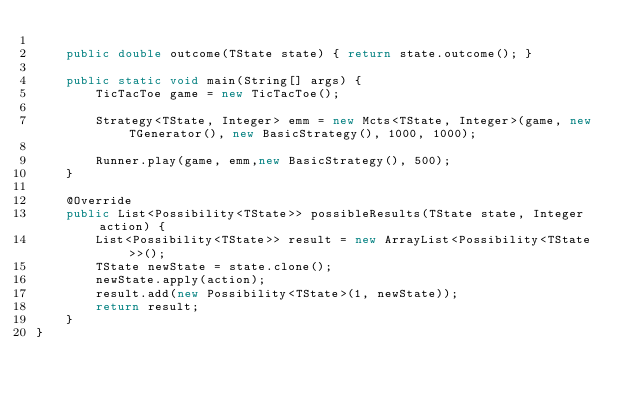<code> <loc_0><loc_0><loc_500><loc_500><_Java_>	
	public double outcome(TState state) { return state.outcome(); }
	
    public static void main(String[] args) {
		TicTacToe game = new TicTacToe();
				
		Strategy<TState, Integer> emm = new Mcts<TState, Integer>(game, new TGenerator(), new BasicStrategy(), 1000, 1000); 
		
		Runner.play(game, emm,new BasicStrategy(), 500);
	}

	@Override
	public List<Possibility<TState>> possibleResults(TState state, Integer action) {
		List<Possibility<TState>> result = new ArrayList<Possibility<TState>>();
		TState newState = state.clone();
		newState.apply(action);
		result.add(new Possibility<TState>(1, newState));
		return result;
	}
}</code> 